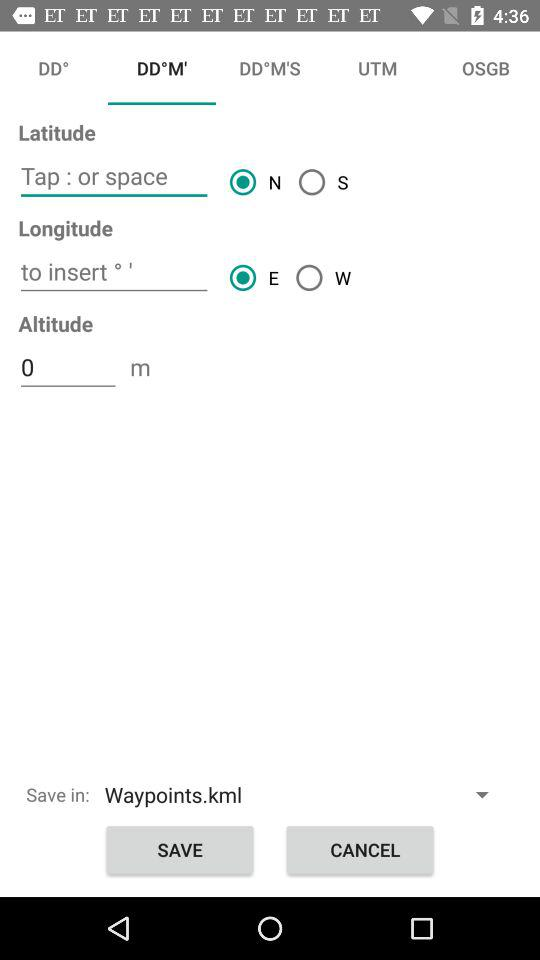Which option has the east selected direction? The option is "Longitude". 